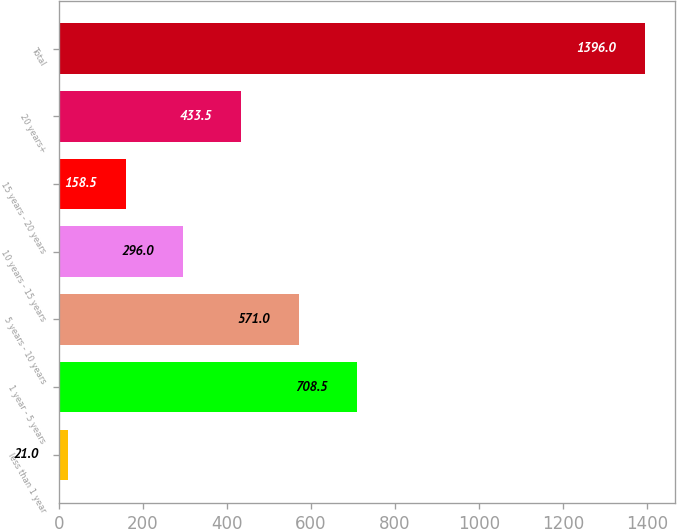<chart> <loc_0><loc_0><loc_500><loc_500><bar_chart><fcel>less than 1 year<fcel>1 year - 5 years<fcel>5 years - 10 years<fcel>10 years - 15 years<fcel>15 years - 20 years<fcel>20 years+<fcel>Total<nl><fcel>21<fcel>708.5<fcel>571<fcel>296<fcel>158.5<fcel>433.5<fcel>1396<nl></chart> 